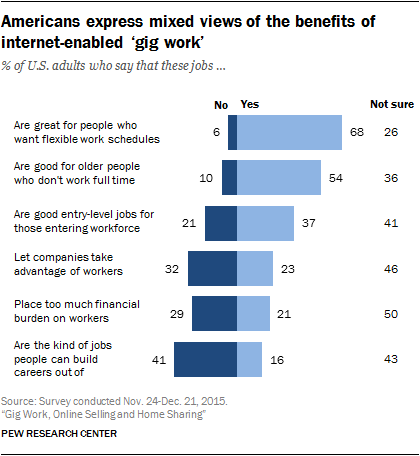Give some essential details in this illustration. The dark blue color in the graph represents "No" vote in the referendum. The average response to the question "What is the average share of 'Not sure' opinion?" was 40.333333... 